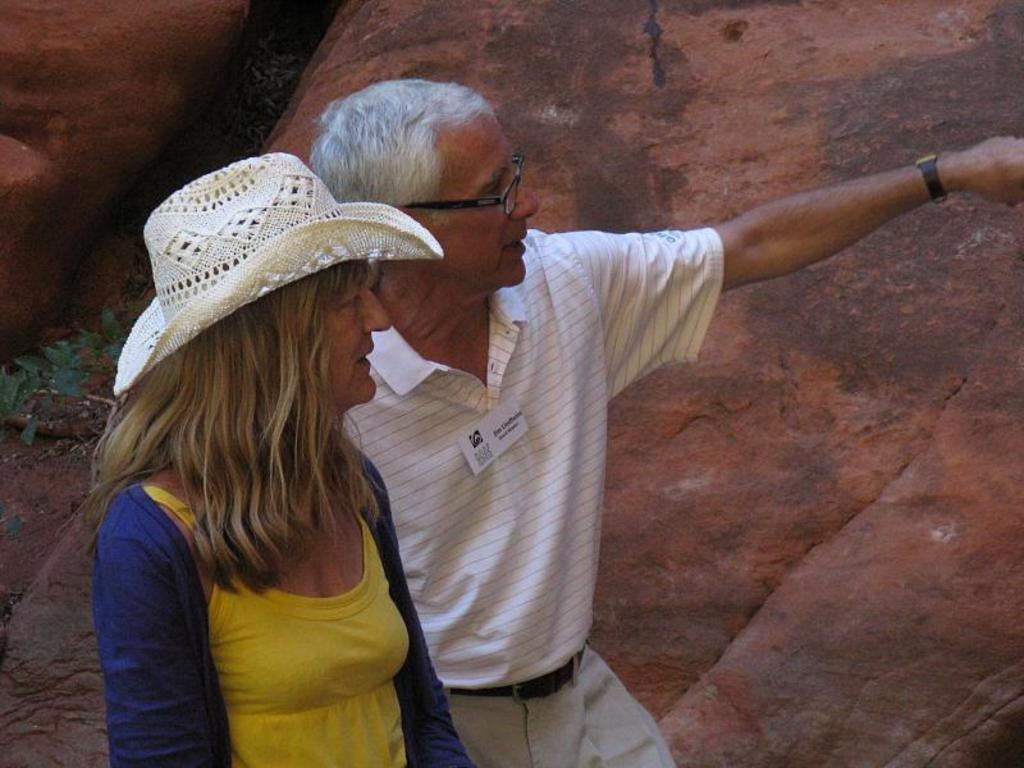How many people are in the image? There are two people in the image. Where are the two people located in the image? The two people are on the left side of the image. What can be seen in the background of the image? There is a rock in the background of the image. What type of meal are the two people eating in the image? There is no meal present in the image; it only shows two people and a rock in the background. 